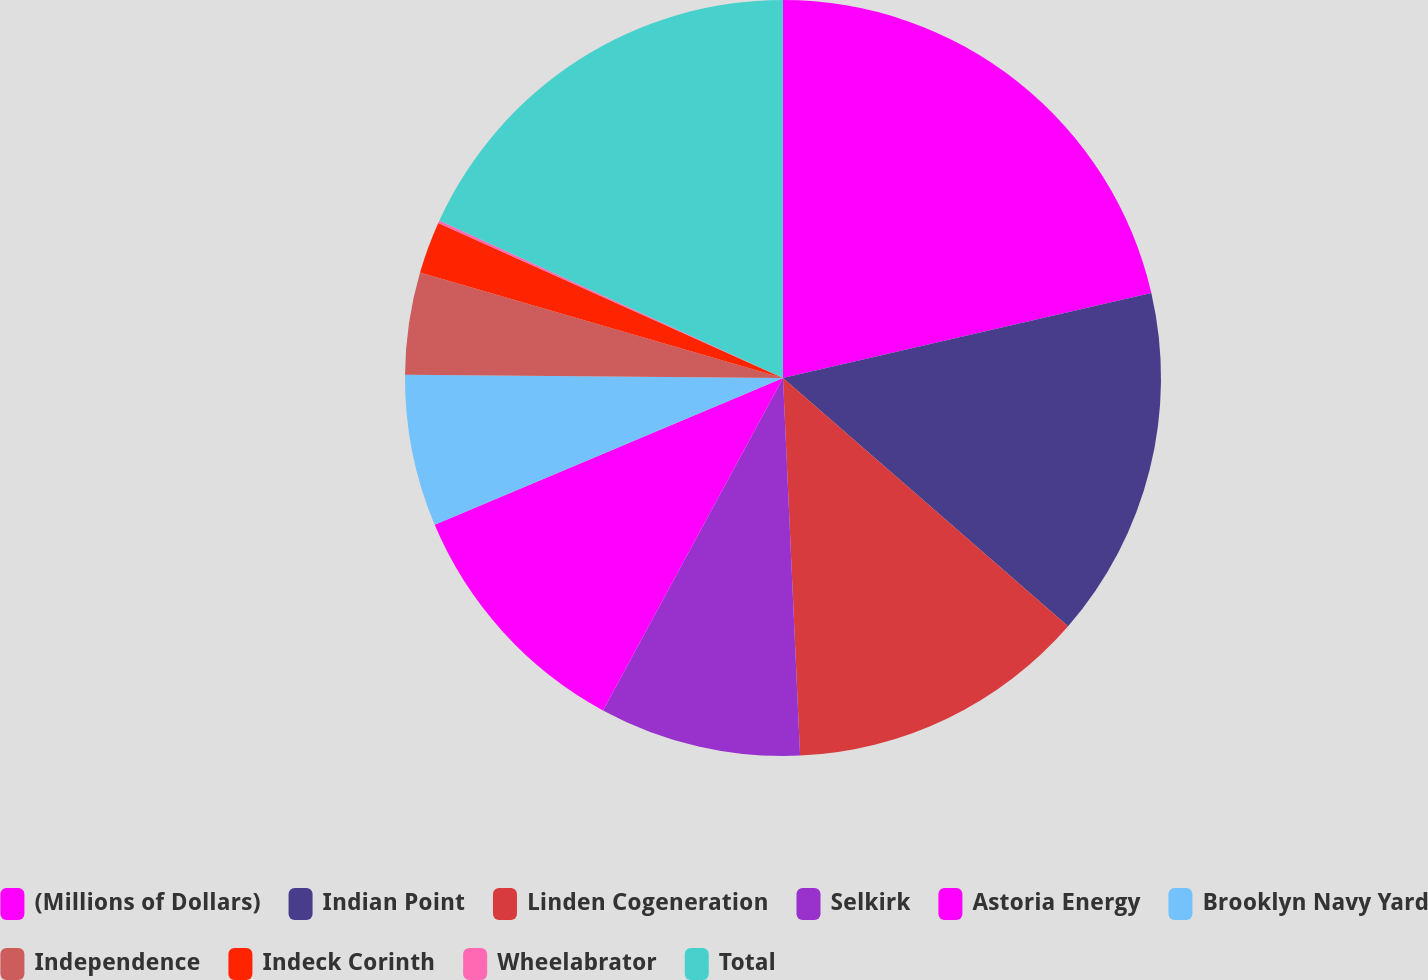<chart> <loc_0><loc_0><loc_500><loc_500><pie_chart><fcel>(Millions of Dollars)<fcel>Indian Point<fcel>Linden Cogeneration<fcel>Selkirk<fcel>Astoria Energy<fcel>Brooklyn Navy Yard<fcel>Independence<fcel>Indeck Corinth<fcel>Wheelabrator<fcel>Total<nl><fcel>21.39%<fcel>15.01%<fcel>12.88%<fcel>8.62%<fcel>10.75%<fcel>6.49%<fcel>4.36%<fcel>2.23%<fcel>0.11%<fcel>18.16%<nl></chart> 